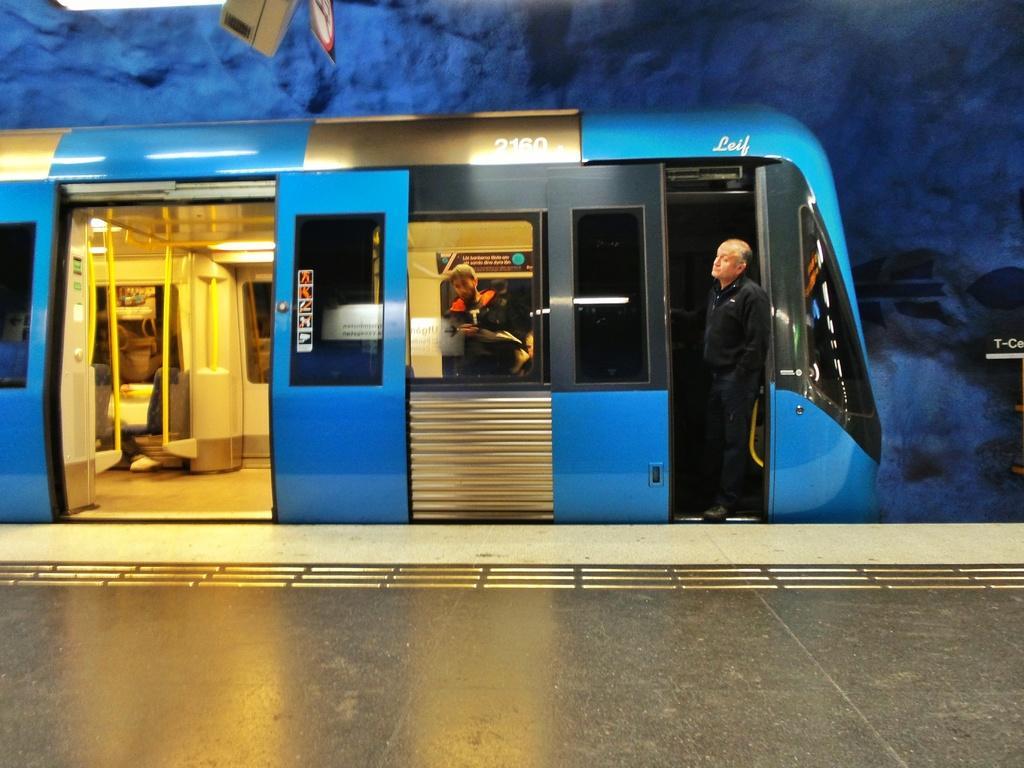In one or two sentences, can you explain what this image depicts? In this picture we can see few people in the train, and we can find few metal rods, lights. 